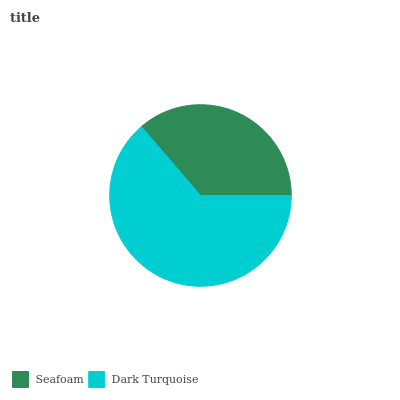Is Seafoam the minimum?
Answer yes or no. Yes. Is Dark Turquoise the maximum?
Answer yes or no. Yes. Is Dark Turquoise the minimum?
Answer yes or no. No. Is Dark Turquoise greater than Seafoam?
Answer yes or no. Yes. Is Seafoam less than Dark Turquoise?
Answer yes or no. Yes. Is Seafoam greater than Dark Turquoise?
Answer yes or no. No. Is Dark Turquoise less than Seafoam?
Answer yes or no. No. Is Dark Turquoise the high median?
Answer yes or no. Yes. Is Seafoam the low median?
Answer yes or no. Yes. Is Seafoam the high median?
Answer yes or no. No. Is Dark Turquoise the low median?
Answer yes or no. No. 